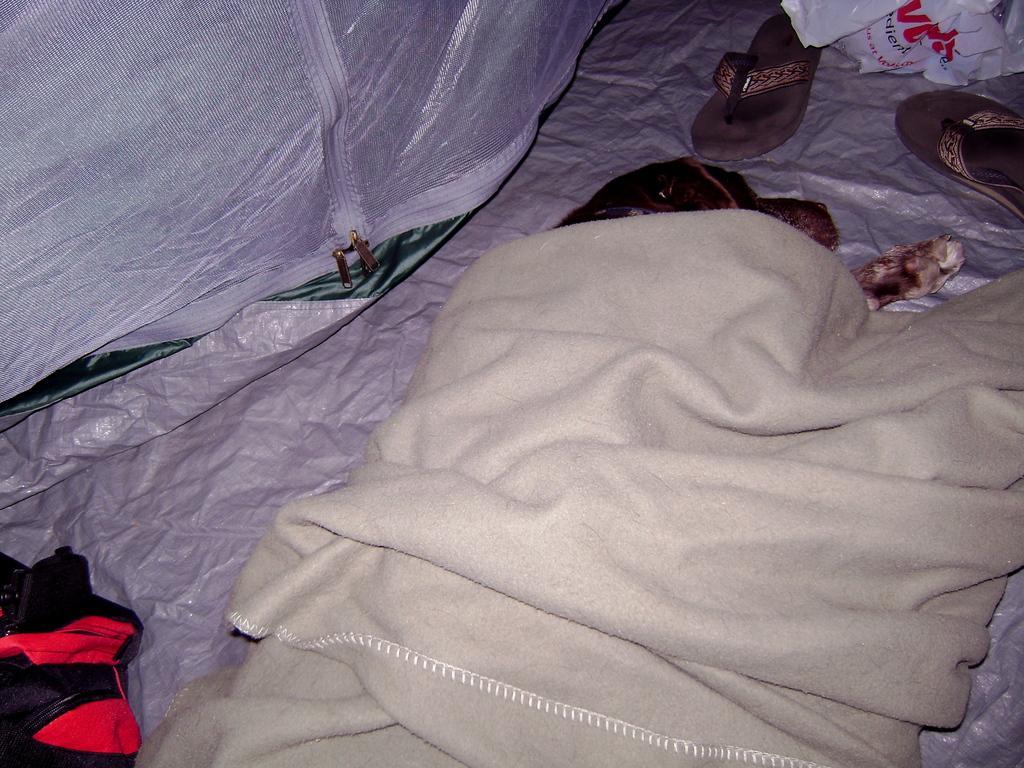Describe this image in one or two sentences. There is a dog sleeping and there is a cloth covered on it and there is a pair of footwear in front of it. 